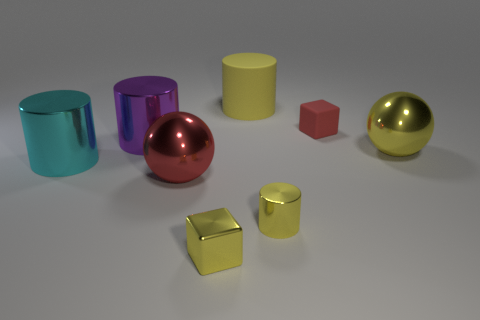Subtract all large cylinders. How many cylinders are left? 1 Add 1 big cyan things. How many objects exist? 9 Subtract all cyan cubes. How many yellow cylinders are left? 2 Subtract all purple cylinders. How many cylinders are left? 3 Subtract 2 blocks. How many blocks are left? 0 Subtract all balls. How many objects are left? 6 Add 4 small blocks. How many small blocks are left? 6 Add 3 small yellow shiny cylinders. How many small yellow shiny cylinders exist? 4 Subtract 0 purple blocks. How many objects are left? 8 Subtract all brown cubes. Subtract all purple spheres. How many cubes are left? 2 